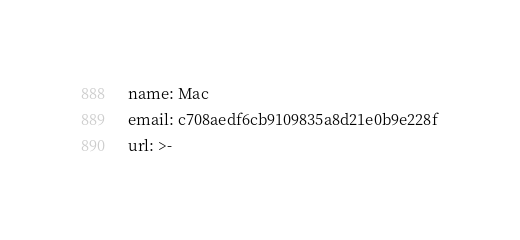Convert code to text. <code><loc_0><loc_0><loc_500><loc_500><_YAML_>name: Mac
email: c708aedf6cb9109835a8d21e0b9e228f
url: >-</code> 